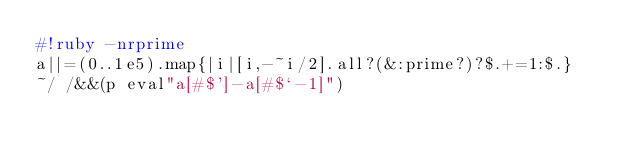<code> <loc_0><loc_0><loc_500><loc_500><_Ruby_>#!ruby -nrprime
a||=(0..1e5).map{|i|[i,-~i/2].all?(&:prime?)?$.+=1:$.}
~/ /&&(p eval"a[#$']-a[#$`-1]")</code> 